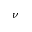Convert formula to latex. <formula><loc_0><loc_0><loc_500><loc_500>\nu</formula> 